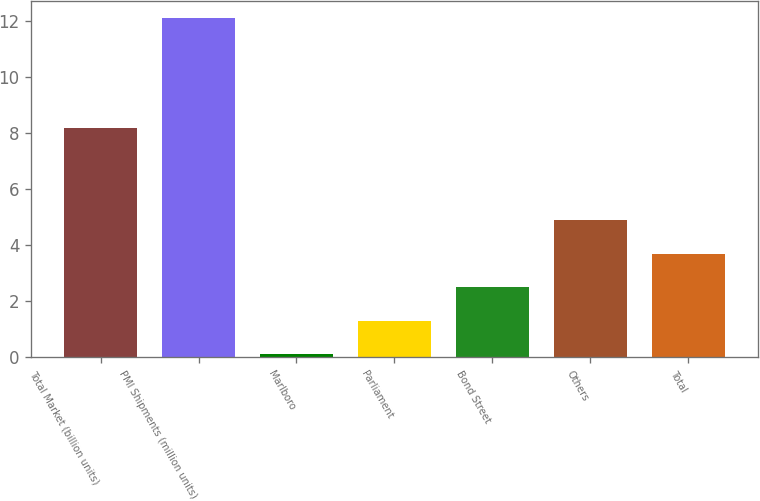Convert chart to OTSL. <chart><loc_0><loc_0><loc_500><loc_500><bar_chart><fcel>Total Market (billion units)<fcel>PMI Shipments (million units)<fcel>Marlboro<fcel>Parliament<fcel>Bond Street<fcel>Others<fcel>Total<nl><fcel>8.2<fcel>12.1<fcel>0.1<fcel>1.3<fcel>2.5<fcel>4.9<fcel>3.7<nl></chart> 